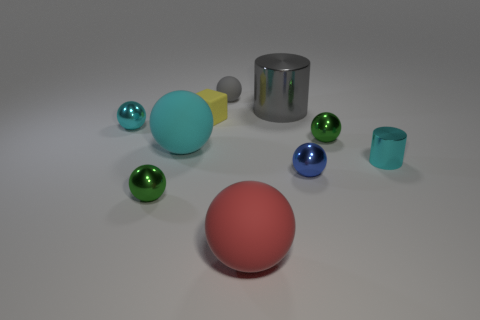Subtract all big matte spheres. How many spheres are left? 5 Subtract all cyan balls. How many balls are left? 5 Subtract 2 cylinders. How many cylinders are left? 0 Subtract all red blocks. How many brown cylinders are left? 0 Subtract all metal objects. Subtract all cyan metal spheres. How many objects are left? 3 Add 1 cyan things. How many cyan things are left? 4 Add 2 blocks. How many blocks exist? 3 Subtract 0 red cylinders. How many objects are left? 10 Subtract all cubes. How many objects are left? 9 Subtract all cyan cylinders. Subtract all cyan balls. How many cylinders are left? 1 